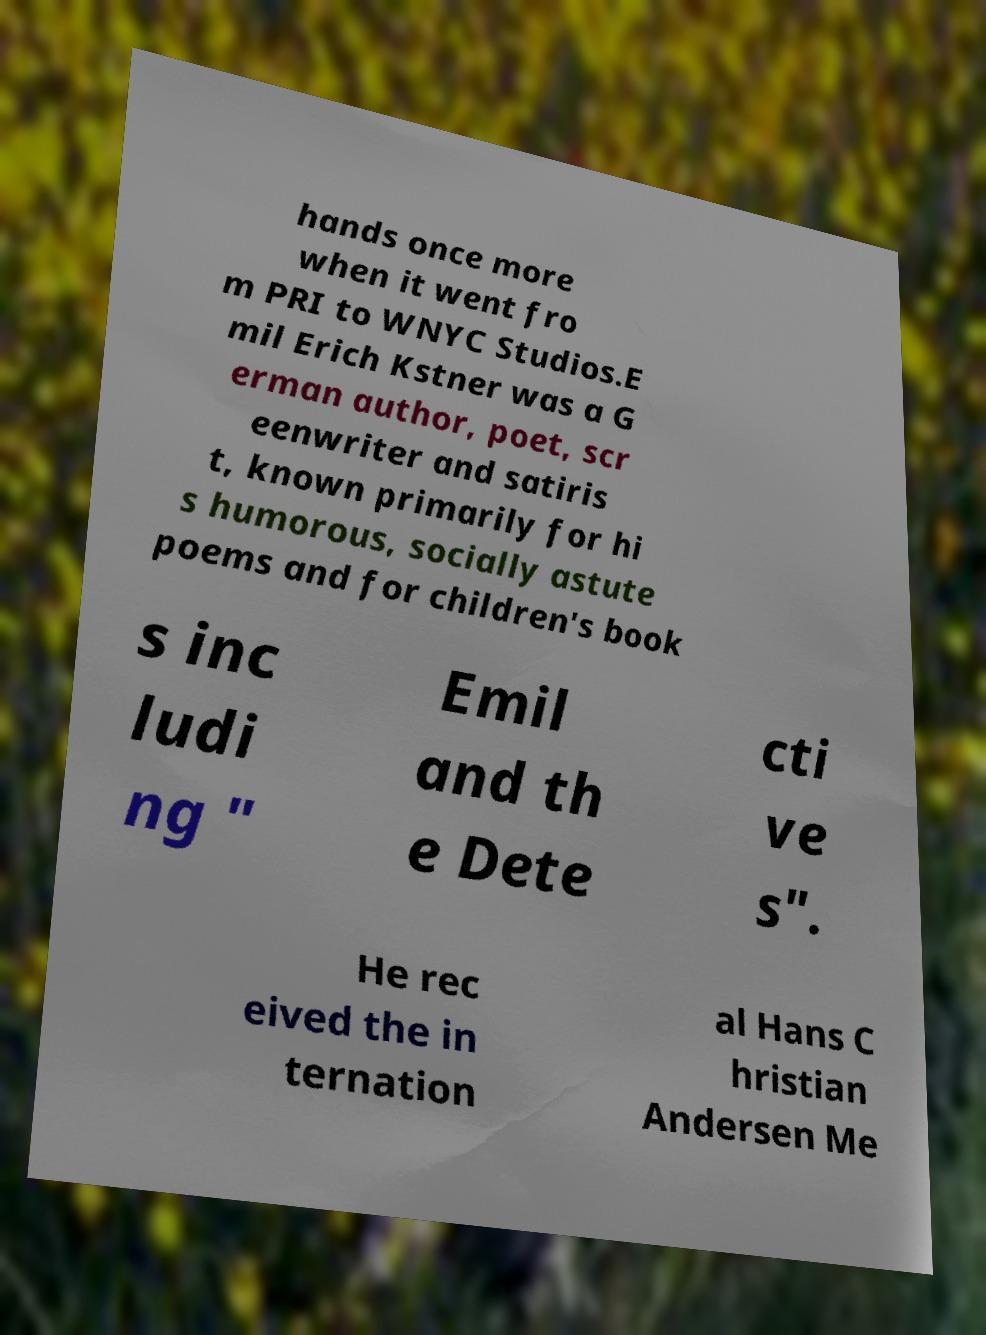Please read and relay the text visible in this image. What does it say? hands once more when it went fro m PRI to WNYC Studios.E mil Erich Kstner was a G erman author, poet, scr eenwriter and satiris t, known primarily for hi s humorous, socially astute poems and for children's book s inc ludi ng " Emil and th e Dete cti ve s". He rec eived the in ternation al Hans C hristian Andersen Me 